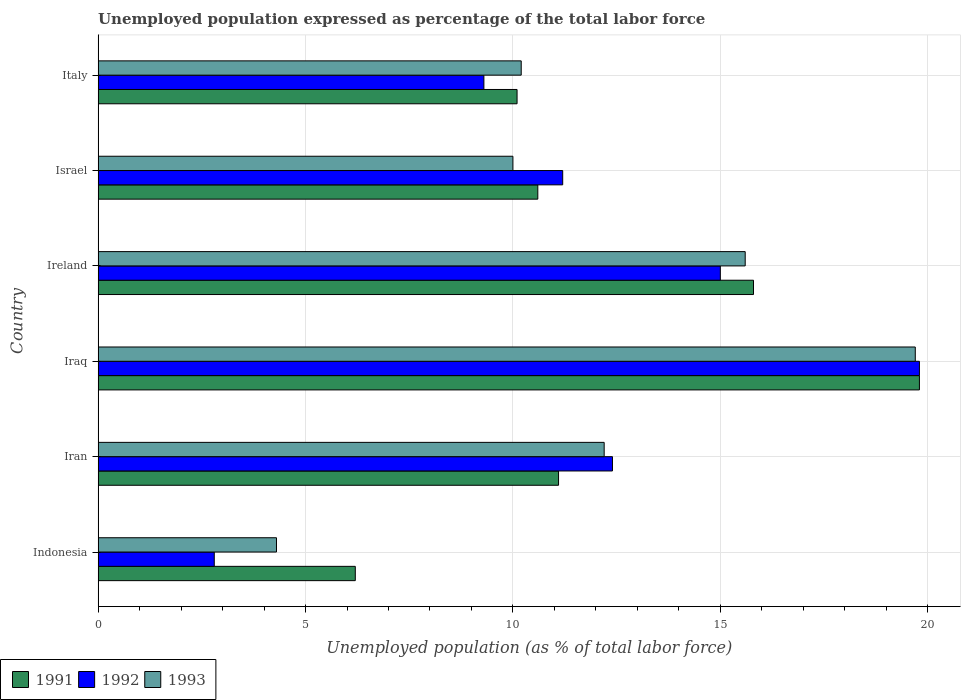How many groups of bars are there?
Ensure brevity in your answer.  6. Are the number of bars on each tick of the Y-axis equal?
Your answer should be compact. Yes. How many bars are there on the 1st tick from the top?
Keep it short and to the point. 3. How many bars are there on the 6th tick from the bottom?
Offer a very short reply. 3. What is the label of the 4th group of bars from the top?
Your answer should be very brief. Iraq. In how many cases, is the number of bars for a given country not equal to the number of legend labels?
Offer a terse response. 0. Across all countries, what is the maximum unemployment in in 1991?
Ensure brevity in your answer.  19.8. Across all countries, what is the minimum unemployment in in 1993?
Keep it short and to the point. 4.3. In which country was the unemployment in in 1993 maximum?
Ensure brevity in your answer.  Iraq. In which country was the unemployment in in 1993 minimum?
Provide a short and direct response. Indonesia. What is the total unemployment in in 1993 in the graph?
Give a very brief answer. 72. What is the difference between the unemployment in in 1993 in Iran and that in Iraq?
Give a very brief answer. -7.5. What is the difference between the unemployment in in 1992 in Israel and the unemployment in in 1991 in Iran?
Offer a very short reply. 0.1. What is the average unemployment in in 1992 per country?
Offer a very short reply. 11.75. What is the difference between the unemployment in in 1992 and unemployment in in 1991 in Iran?
Your answer should be compact. 1.3. What is the ratio of the unemployment in in 1991 in Indonesia to that in Iraq?
Give a very brief answer. 0.31. Is the unemployment in in 1993 in Ireland less than that in Italy?
Your response must be concise. No. What is the difference between the highest and the second highest unemployment in in 1992?
Provide a short and direct response. 4.8. What is the difference between the highest and the lowest unemployment in in 1993?
Ensure brevity in your answer.  15.4. How many bars are there?
Your answer should be compact. 18. Are all the bars in the graph horizontal?
Your answer should be very brief. Yes. How many countries are there in the graph?
Your answer should be compact. 6. Does the graph contain grids?
Your answer should be very brief. Yes. Where does the legend appear in the graph?
Provide a short and direct response. Bottom left. How are the legend labels stacked?
Offer a very short reply. Horizontal. What is the title of the graph?
Give a very brief answer. Unemployed population expressed as percentage of the total labor force. Does "2004" appear as one of the legend labels in the graph?
Offer a terse response. No. What is the label or title of the X-axis?
Offer a very short reply. Unemployed population (as % of total labor force). What is the label or title of the Y-axis?
Make the answer very short. Country. What is the Unemployed population (as % of total labor force) in 1991 in Indonesia?
Offer a terse response. 6.2. What is the Unemployed population (as % of total labor force) in 1992 in Indonesia?
Offer a very short reply. 2.8. What is the Unemployed population (as % of total labor force) of 1993 in Indonesia?
Ensure brevity in your answer.  4.3. What is the Unemployed population (as % of total labor force) in 1991 in Iran?
Offer a terse response. 11.1. What is the Unemployed population (as % of total labor force) in 1992 in Iran?
Make the answer very short. 12.4. What is the Unemployed population (as % of total labor force) of 1993 in Iran?
Offer a very short reply. 12.2. What is the Unemployed population (as % of total labor force) of 1991 in Iraq?
Your answer should be compact. 19.8. What is the Unemployed population (as % of total labor force) of 1992 in Iraq?
Offer a terse response. 19.8. What is the Unemployed population (as % of total labor force) in 1993 in Iraq?
Your response must be concise. 19.7. What is the Unemployed population (as % of total labor force) in 1991 in Ireland?
Make the answer very short. 15.8. What is the Unemployed population (as % of total labor force) in 1993 in Ireland?
Offer a terse response. 15.6. What is the Unemployed population (as % of total labor force) in 1991 in Israel?
Ensure brevity in your answer.  10.6. What is the Unemployed population (as % of total labor force) of 1992 in Israel?
Offer a very short reply. 11.2. What is the Unemployed population (as % of total labor force) in 1991 in Italy?
Offer a very short reply. 10.1. What is the Unemployed population (as % of total labor force) in 1992 in Italy?
Your answer should be very brief. 9.3. What is the Unemployed population (as % of total labor force) of 1993 in Italy?
Your response must be concise. 10.2. Across all countries, what is the maximum Unemployed population (as % of total labor force) in 1991?
Ensure brevity in your answer.  19.8. Across all countries, what is the maximum Unemployed population (as % of total labor force) in 1992?
Give a very brief answer. 19.8. Across all countries, what is the maximum Unemployed population (as % of total labor force) of 1993?
Provide a short and direct response. 19.7. Across all countries, what is the minimum Unemployed population (as % of total labor force) in 1991?
Provide a succinct answer. 6.2. Across all countries, what is the minimum Unemployed population (as % of total labor force) in 1992?
Provide a short and direct response. 2.8. Across all countries, what is the minimum Unemployed population (as % of total labor force) of 1993?
Ensure brevity in your answer.  4.3. What is the total Unemployed population (as % of total labor force) of 1991 in the graph?
Your answer should be compact. 73.6. What is the total Unemployed population (as % of total labor force) in 1992 in the graph?
Keep it short and to the point. 70.5. What is the difference between the Unemployed population (as % of total labor force) of 1991 in Indonesia and that in Iran?
Offer a terse response. -4.9. What is the difference between the Unemployed population (as % of total labor force) of 1992 in Indonesia and that in Iran?
Give a very brief answer. -9.6. What is the difference between the Unemployed population (as % of total labor force) in 1993 in Indonesia and that in Iran?
Give a very brief answer. -7.9. What is the difference between the Unemployed population (as % of total labor force) in 1993 in Indonesia and that in Iraq?
Offer a very short reply. -15.4. What is the difference between the Unemployed population (as % of total labor force) in 1991 in Indonesia and that in Ireland?
Your answer should be very brief. -9.6. What is the difference between the Unemployed population (as % of total labor force) in 1992 in Indonesia and that in Ireland?
Offer a very short reply. -12.2. What is the difference between the Unemployed population (as % of total labor force) in 1992 in Indonesia and that in Israel?
Provide a short and direct response. -8.4. What is the difference between the Unemployed population (as % of total labor force) in 1991 in Indonesia and that in Italy?
Provide a succinct answer. -3.9. What is the difference between the Unemployed population (as % of total labor force) in 1993 in Indonesia and that in Italy?
Your answer should be very brief. -5.9. What is the difference between the Unemployed population (as % of total labor force) in 1993 in Iran and that in Iraq?
Keep it short and to the point. -7.5. What is the difference between the Unemployed population (as % of total labor force) in 1991 in Iran and that in Israel?
Your response must be concise. 0.5. What is the difference between the Unemployed population (as % of total labor force) in 1992 in Iran and that in Israel?
Keep it short and to the point. 1.2. What is the difference between the Unemployed population (as % of total labor force) in 1991 in Iran and that in Italy?
Ensure brevity in your answer.  1. What is the difference between the Unemployed population (as % of total labor force) in 1991 in Iraq and that in Ireland?
Make the answer very short. 4. What is the difference between the Unemployed population (as % of total labor force) in 1991 in Iraq and that in Israel?
Provide a short and direct response. 9.2. What is the difference between the Unemployed population (as % of total labor force) in 1992 in Iraq and that in Israel?
Provide a short and direct response. 8.6. What is the difference between the Unemployed population (as % of total labor force) of 1991 in Iraq and that in Italy?
Keep it short and to the point. 9.7. What is the difference between the Unemployed population (as % of total labor force) of 1992 in Iraq and that in Italy?
Your response must be concise. 10.5. What is the difference between the Unemployed population (as % of total labor force) of 1992 in Ireland and that in Israel?
Provide a succinct answer. 3.8. What is the difference between the Unemployed population (as % of total labor force) of 1991 in Israel and that in Italy?
Make the answer very short. 0.5. What is the difference between the Unemployed population (as % of total labor force) in 1993 in Israel and that in Italy?
Ensure brevity in your answer.  -0.2. What is the difference between the Unemployed population (as % of total labor force) of 1991 in Indonesia and the Unemployed population (as % of total labor force) of 1992 in Iran?
Give a very brief answer. -6.2. What is the difference between the Unemployed population (as % of total labor force) in 1992 in Indonesia and the Unemployed population (as % of total labor force) in 1993 in Iraq?
Provide a short and direct response. -16.9. What is the difference between the Unemployed population (as % of total labor force) of 1991 in Indonesia and the Unemployed population (as % of total labor force) of 1992 in Ireland?
Your response must be concise. -8.8. What is the difference between the Unemployed population (as % of total labor force) in 1992 in Indonesia and the Unemployed population (as % of total labor force) in 1993 in Ireland?
Offer a terse response. -12.8. What is the difference between the Unemployed population (as % of total labor force) in 1991 in Indonesia and the Unemployed population (as % of total labor force) in 1992 in Israel?
Offer a terse response. -5. What is the difference between the Unemployed population (as % of total labor force) of 1991 in Indonesia and the Unemployed population (as % of total labor force) of 1993 in Israel?
Provide a short and direct response. -3.8. What is the difference between the Unemployed population (as % of total labor force) in 1991 in Indonesia and the Unemployed population (as % of total labor force) in 1992 in Italy?
Keep it short and to the point. -3.1. What is the difference between the Unemployed population (as % of total labor force) in 1991 in Indonesia and the Unemployed population (as % of total labor force) in 1993 in Italy?
Offer a terse response. -4. What is the difference between the Unemployed population (as % of total labor force) of 1992 in Iran and the Unemployed population (as % of total labor force) of 1993 in Iraq?
Your response must be concise. -7.3. What is the difference between the Unemployed population (as % of total labor force) of 1991 in Iran and the Unemployed population (as % of total labor force) of 1993 in Ireland?
Your answer should be very brief. -4.5. What is the difference between the Unemployed population (as % of total labor force) of 1991 in Iran and the Unemployed population (as % of total labor force) of 1992 in Israel?
Ensure brevity in your answer.  -0.1. What is the difference between the Unemployed population (as % of total labor force) in 1991 in Iran and the Unemployed population (as % of total labor force) in 1993 in Israel?
Keep it short and to the point. 1.1. What is the difference between the Unemployed population (as % of total labor force) in 1991 in Iran and the Unemployed population (as % of total labor force) in 1992 in Italy?
Provide a short and direct response. 1.8. What is the difference between the Unemployed population (as % of total labor force) in 1991 in Iraq and the Unemployed population (as % of total labor force) in 1992 in Ireland?
Your response must be concise. 4.8. What is the difference between the Unemployed population (as % of total labor force) in 1992 in Iraq and the Unemployed population (as % of total labor force) in 1993 in Ireland?
Your response must be concise. 4.2. What is the difference between the Unemployed population (as % of total labor force) in 1992 in Iraq and the Unemployed population (as % of total labor force) in 1993 in Israel?
Provide a short and direct response. 9.8. What is the difference between the Unemployed population (as % of total labor force) of 1991 in Iraq and the Unemployed population (as % of total labor force) of 1993 in Italy?
Keep it short and to the point. 9.6. What is the difference between the Unemployed population (as % of total labor force) in 1992 in Iraq and the Unemployed population (as % of total labor force) in 1993 in Italy?
Offer a terse response. 9.6. What is the difference between the Unemployed population (as % of total labor force) in 1991 in Ireland and the Unemployed population (as % of total labor force) in 1992 in Israel?
Your answer should be compact. 4.6. What is the difference between the Unemployed population (as % of total labor force) of 1992 in Ireland and the Unemployed population (as % of total labor force) of 1993 in Israel?
Give a very brief answer. 5. What is the difference between the Unemployed population (as % of total labor force) of 1991 in Ireland and the Unemployed population (as % of total labor force) of 1993 in Italy?
Your response must be concise. 5.6. What is the difference between the Unemployed population (as % of total labor force) in 1991 in Israel and the Unemployed population (as % of total labor force) in 1993 in Italy?
Your response must be concise. 0.4. What is the average Unemployed population (as % of total labor force) of 1991 per country?
Keep it short and to the point. 12.27. What is the average Unemployed population (as % of total labor force) in 1992 per country?
Provide a short and direct response. 11.75. What is the difference between the Unemployed population (as % of total labor force) in 1991 and Unemployed population (as % of total labor force) in 1993 in Indonesia?
Ensure brevity in your answer.  1.9. What is the difference between the Unemployed population (as % of total labor force) in 1992 and Unemployed population (as % of total labor force) in 1993 in Indonesia?
Give a very brief answer. -1.5. What is the difference between the Unemployed population (as % of total labor force) of 1991 and Unemployed population (as % of total labor force) of 1993 in Iran?
Provide a short and direct response. -1.1. What is the difference between the Unemployed population (as % of total labor force) of 1991 and Unemployed population (as % of total labor force) of 1992 in Iraq?
Offer a very short reply. 0. What is the difference between the Unemployed population (as % of total labor force) of 1992 and Unemployed population (as % of total labor force) of 1993 in Israel?
Your answer should be very brief. 1.2. What is the difference between the Unemployed population (as % of total labor force) in 1991 and Unemployed population (as % of total labor force) in 1992 in Italy?
Make the answer very short. 0.8. What is the ratio of the Unemployed population (as % of total labor force) of 1991 in Indonesia to that in Iran?
Provide a short and direct response. 0.56. What is the ratio of the Unemployed population (as % of total labor force) in 1992 in Indonesia to that in Iran?
Make the answer very short. 0.23. What is the ratio of the Unemployed population (as % of total labor force) of 1993 in Indonesia to that in Iran?
Make the answer very short. 0.35. What is the ratio of the Unemployed population (as % of total labor force) of 1991 in Indonesia to that in Iraq?
Your answer should be very brief. 0.31. What is the ratio of the Unemployed population (as % of total labor force) of 1992 in Indonesia to that in Iraq?
Make the answer very short. 0.14. What is the ratio of the Unemployed population (as % of total labor force) of 1993 in Indonesia to that in Iraq?
Provide a succinct answer. 0.22. What is the ratio of the Unemployed population (as % of total labor force) of 1991 in Indonesia to that in Ireland?
Make the answer very short. 0.39. What is the ratio of the Unemployed population (as % of total labor force) in 1992 in Indonesia to that in Ireland?
Provide a succinct answer. 0.19. What is the ratio of the Unemployed population (as % of total labor force) of 1993 in Indonesia to that in Ireland?
Provide a succinct answer. 0.28. What is the ratio of the Unemployed population (as % of total labor force) of 1991 in Indonesia to that in Israel?
Give a very brief answer. 0.58. What is the ratio of the Unemployed population (as % of total labor force) of 1992 in Indonesia to that in Israel?
Provide a short and direct response. 0.25. What is the ratio of the Unemployed population (as % of total labor force) in 1993 in Indonesia to that in Israel?
Ensure brevity in your answer.  0.43. What is the ratio of the Unemployed population (as % of total labor force) of 1991 in Indonesia to that in Italy?
Ensure brevity in your answer.  0.61. What is the ratio of the Unemployed population (as % of total labor force) in 1992 in Indonesia to that in Italy?
Provide a succinct answer. 0.3. What is the ratio of the Unemployed population (as % of total labor force) of 1993 in Indonesia to that in Italy?
Make the answer very short. 0.42. What is the ratio of the Unemployed population (as % of total labor force) in 1991 in Iran to that in Iraq?
Provide a succinct answer. 0.56. What is the ratio of the Unemployed population (as % of total labor force) in 1992 in Iran to that in Iraq?
Provide a short and direct response. 0.63. What is the ratio of the Unemployed population (as % of total labor force) of 1993 in Iran to that in Iraq?
Your answer should be compact. 0.62. What is the ratio of the Unemployed population (as % of total labor force) in 1991 in Iran to that in Ireland?
Keep it short and to the point. 0.7. What is the ratio of the Unemployed population (as % of total labor force) of 1992 in Iran to that in Ireland?
Your answer should be compact. 0.83. What is the ratio of the Unemployed population (as % of total labor force) in 1993 in Iran to that in Ireland?
Give a very brief answer. 0.78. What is the ratio of the Unemployed population (as % of total labor force) in 1991 in Iran to that in Israel?
Your response must be concise. 1.05. What is the ratio of the Unemployed population (as % of total labor force) in 1992 in Iran to that in Israel?
Make the answer very short. 1.11. What is the ratio of the Unemployed population (as % of total labor force) in 1993 in Iran to that in Israel?
Your answer should be very brief. 1.22. What is the ratio of the Unemployed population (as % of total labor force) in 1991 in Iran to that in Italy?
Your answer should be very brief. 1.1. What is the ratio of the Unemployed population (as % of total labor force) in 1993 in Iran to that in Italy?
Offer a very short reply. 1.2. What is the ratio of the Unemployed population (as % of total labor force) in 1991 in Iraq to that in Ireland?
Your answer should be very brief. 1.25. What is the ratio of the Unemployed population (as % of total labor force) of 1992 in Iraq to that in Ireland?
Your answer should be compact. 1.32. What is the ratio of the Unemployed population (as % of total labor force) of 1993 in Iraq to that in Ireland?
Provide a short and direct response. 1.26. What is the ratio of the Unemployed population (as % of total labor force) of 1991 in Iraq to that in Israel?
Your response must be concise. 1.87. What is the ratio of the Unemployed population (as % of total labor force) of 1992 in Iraq to that in Israel?
Offer a very short reply. 1.77. What is the ratio of the Unemployed population (as % of total labor force) of 1993 in Iraq to that in Israel?
Your answer should be very brief. 1.97. What is the ratio of the Unemployed population (as % of total labor force) of 1991 in Iraq to that in Italy?
Ensure brevity in your answer.  1.96. What is the ratio of the Unemployed population (as % of total labor force) in 1992 in Iraq to that in Italy?
Ensure brevity in your answer.  2.13. What is the ratio of the Unemployed population (as % of total labor force) of 1993 in Iraq to that in Italy?
Offer a terse response. 1.93. What is the ratio of the Unemployed population (as % of total labor force) of 1991 in Ireland to that in Israel?
Keep it short and to the point. 1.49. What is the ratio of the Unemployed population (as % of total labor force) in 1992 in Ireland to that in Israel?
Give a very brief answer. 1.34. What is the ratio of the Unemployed population (as % of total labor force) in 1993 in Ireland to that in Israel?
Ensure brevity in your answer.  1.56. What is the ratio of the Unemployed population (as % of total labor force) of 1991 in Ireland to that in Italy?
Offer a terse response. 1.56. What is the ratio of the Unemployed population (as % of total labor force) of 1992 in Ireland to that in Italy?
Offer a very short reply. 1.61. What is the ratio of the Unemployed population (as % of total labor force) of 1993 in Ireland to that in Italy?
Make the answer very short. 1.53. What is the ratio of the Unemployed population (as % of total labor force) in 1991 in Israel to that in Italy?
Your answer should be very brief. 1.05. What is the ratio of the Unemployed population (as % of total labor force) in 1992 in Israel to that in Italy?
Your answer should be very brief. 1.2. What is the ratio of the Unemployed population (as % of total labor force) of 1993 in Israel to that in Italy?
Make the answer very short. 0.98. What is the difference between the highest and the second highest Unemployed population (as % of total labor force) in 1992?
Ensure brevity in your answer.  4.8. What is the difference between the highest and the lowest Unemployed population (as % of total labor force) of 1991?
Offer a very short reply. 13.6. What is the difference between the highest and the lowest Unemployed population (as % of total labor force) of 1992?
Keep it short and to the point. 17. 